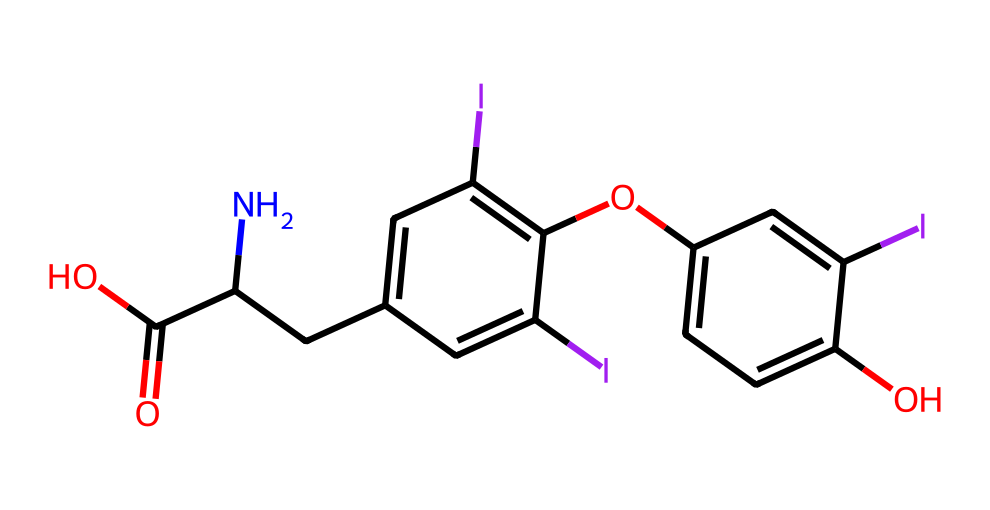What is the molecular formula of the compound represented by the SMILES? To determine the molecular formula, we count the number of each type of atom present in the SMILES. From the notation, we identify the atoms: carbon (C), hydrogen (H), nitrogen (N), and oxygen (O). Careful inspection shows there are 20 carbon atoms, 19 hydrogen atoms, 1 nitrogen atom, and 4 oxygen atoms. Thus, the molecular formula is C20H19N1O4.
Answer: C20H19NO4 How many rings are present in this chemical structure? By analyzing the structure represented through SMILES, we look for cyclic portions of the molecule. The presence of "C1" and "C2" in the SMILES indicates at least two distinct cyclic structures. There are two benzene rings in this structure. Therefore, the total number of rings present is 2.
Answer: 2 What functional groups can be identified in this hormone? By examining the structural features in the SMILES, we note various functional groups including hydroxyl (-OH) groups, carboxylic acid (-COOH), and an ether (-O-) linkage. Specifically, these groups play critical roles in biological reactivity and interactions of the hormone in the body. The significant functional groups identified are hydroxyl and carboxylic acid.
Answer: hydroxyl, carboxylic acid Which atom is responsible for the amine group in this molecule? In the given SMILES, "N" indicates the presence of an amino group (amine functionality) as nitrogen can form an amine when it is attached to carbon. The location of "N" in the structure suggests it is linked to a carbon chain. Thus, the nitrogen atom is responsible for the amine group.
Answer: nitrogen What is the significance of iodine in this structure? Analyzing the presence of iodine (I) in the SMILES, we can relate it to the functionality of the hormone. Thyroxine, a thyroid hormone, contains iodine atoms which are critical for its biological activity and effects on metabolism. Each iodine atom contributes to the biological potency of the thyroid hormones. Therefore, the significance of iodine in this structure is its role in hormonal activity.
Answer: biological potency What type of molecule is represented by this SMILES? The nature of the molecule can be determined from the presence of functional groups and overall structure. Given the presence of iodine, nitrogen, and hydroxyl groups along with a complex molecular structure, it classifies as a hormone, specifically a thyroid hormone like thyroxine.
Answer: hormone 